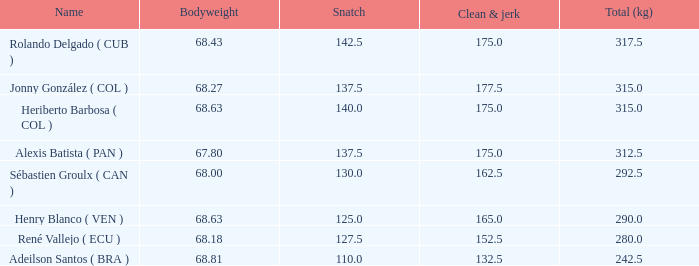Tell me the total number of snatches for clean and jerk more than 132.5 when the total kg was 315 and bodyweight was 68.63 1.0. 